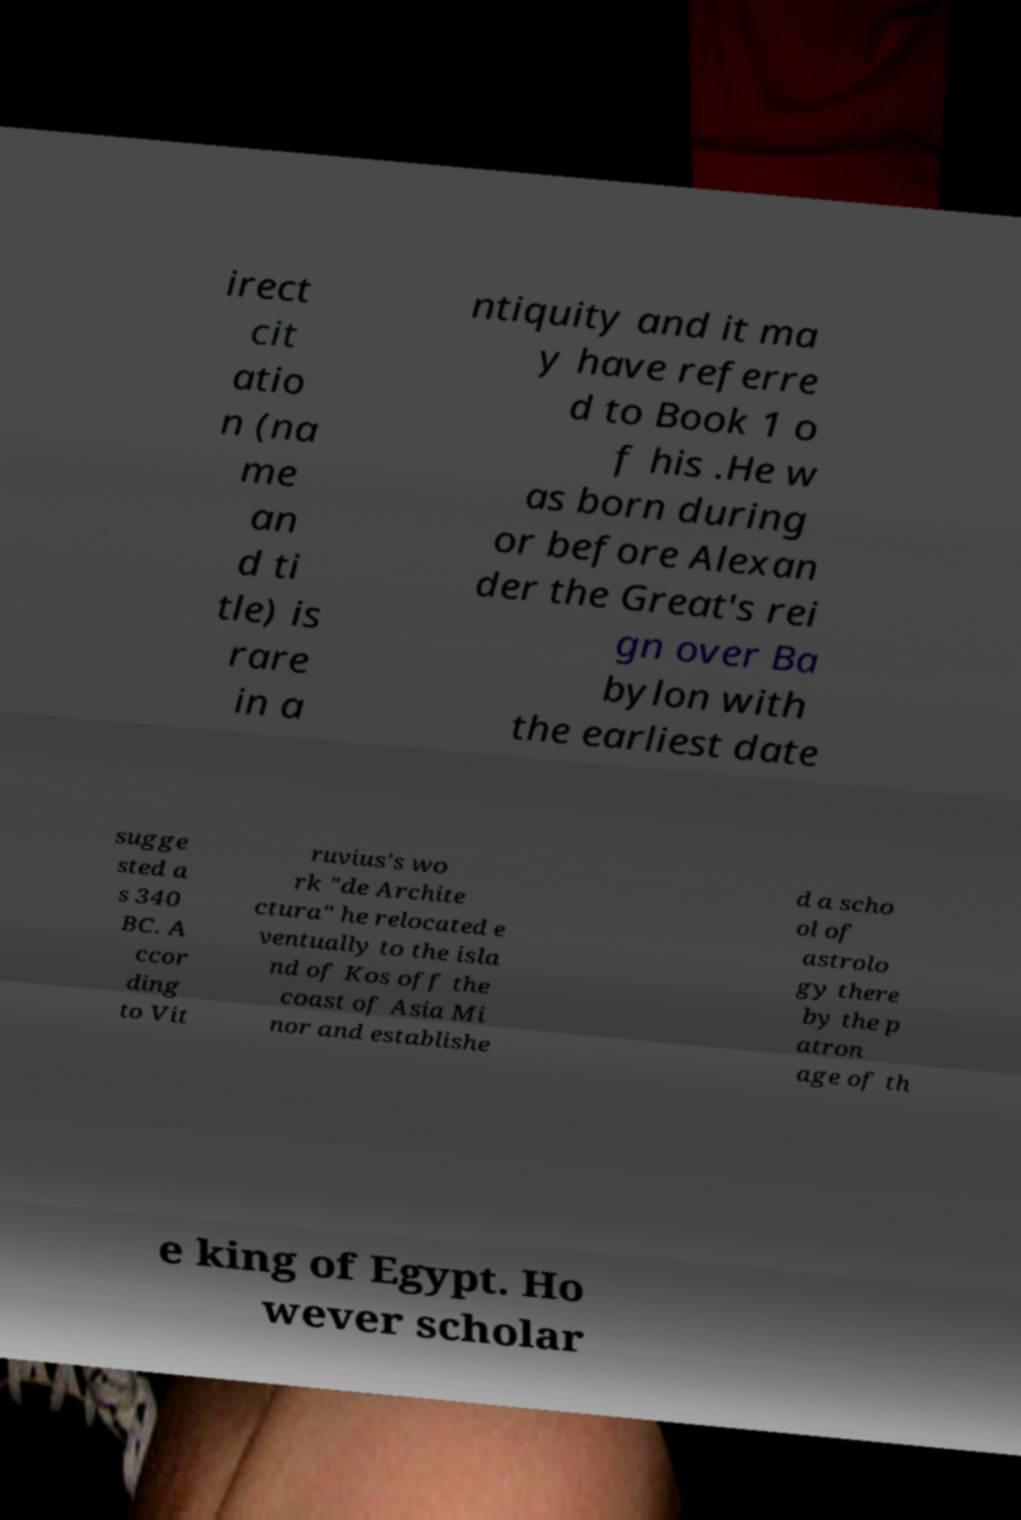Could you extract and type out the text from this image? irect cit atio n (na me an d ti tle) is rare in a ntiquity and it ma y have referre d to Book 1 o f his .He w as born during or before Alexan der the Great's rei gn over Ba bylon with the earliest date sugge sted a s 340 BC. A ccor ding to Vit ruvius's wo rk "de Archite ctura" he relocated e ventually to the isla nd of Kos off the coast of Asia Mi nor and establishe d a scho ol of astrolo gy there by the p atron age of th e king of Egypt. Ho wever scholar 